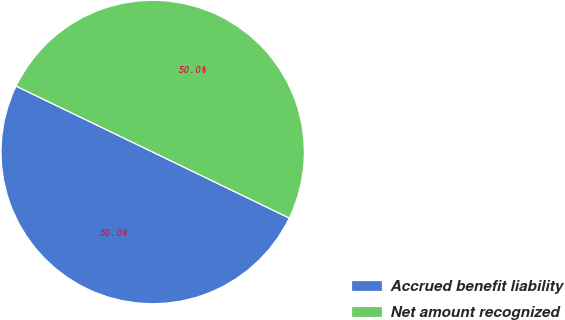<chart> <loc_0><loc_0><loc_500><loc_500><pie_chart><fcel>Accrued benefit liability<fcel>Net amount recognized<nl><fcel>49.99%<fcel>50.01%<nl></chart> 